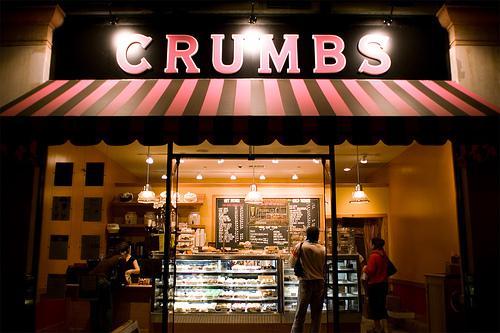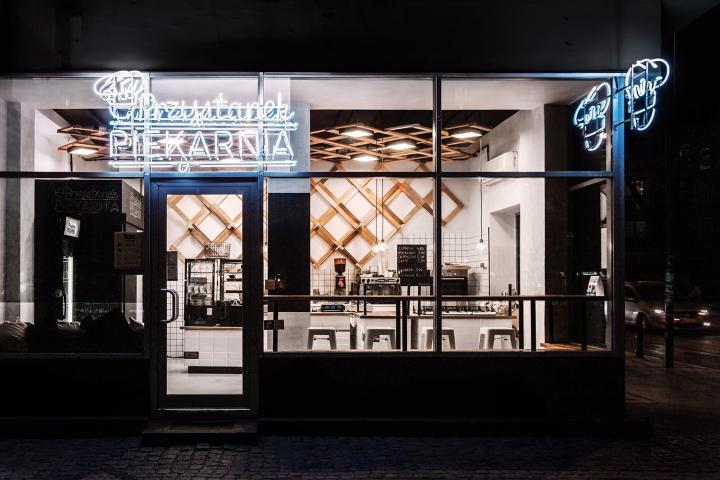The first image is the image on the left, the second image is the image on the right. For the images displayed, is the sentence "An image shows at least one person on the sidewalk in front of the shop in the daytime." factually correct? Answer yes or no. No. 